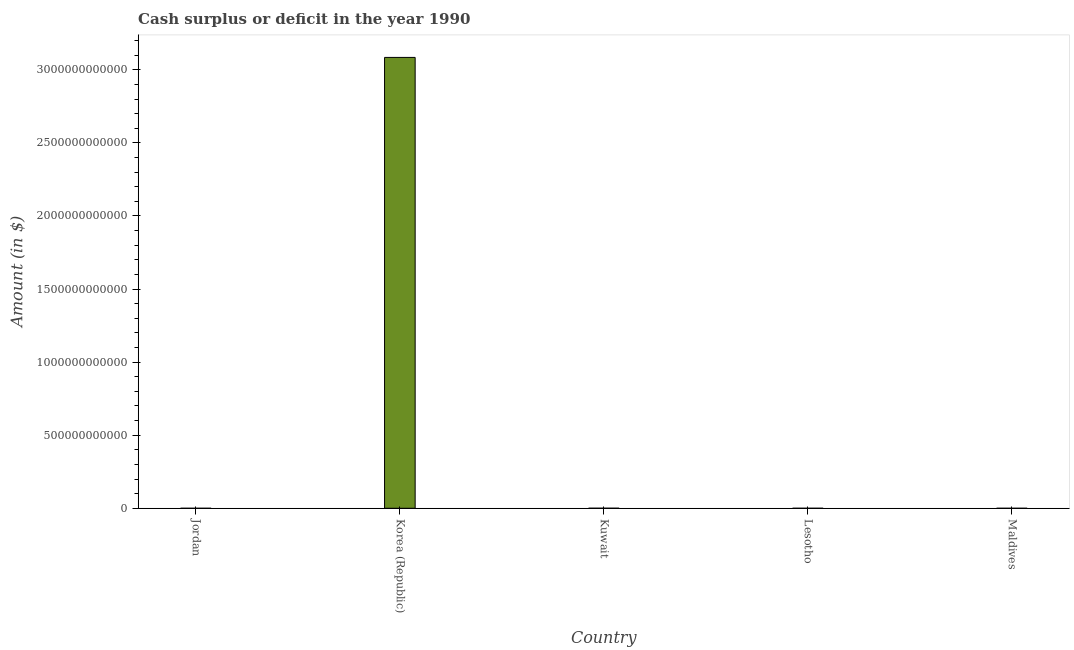What is the title of the graph?
Your answer should be compact. Cash surplus or deficit in the year 1990. What is the label or title of the Y-axis?
Provide a succinct answer. Amount (in $). What is the cash surplus or deficit in Kuwait?
Make the answer very short. 3.23e+08. Across all countries, what is the maximum cash surplus or deficit?
Give a very brief answer. 3.08e+12. In which country was the cash surplus or deficit maximum?
Provide a succinct answer. Korea (Republic). What is the sum of the cash surplus or deficit?
Ensure brevity in your answer.  3.09e+12. What is the average cash surplus or deficit per country?
Your response must be concise. 6.17e+11. What is the ratio of the cash surplus or deficit in Korea (Republic) to that in Kuwait?
Your answer should be compact. 9551.08. What is the difference between the highest and the lowest cash surplus or deficit?
Make the answer very short. 3.08e+12. Are all the bars in the graph horizontal?
Ensure brevity in your answer.  No. What is the difference between two consecutive major ticks on the Y-axis?
Offer a very short reply. 5.00e+11. What is the Amount (in $) of Korea (Republic)?
Provide a succinct answer. 3.08e+12. What is the Amount (in $) of Kuwait?
Give a very brief answer. 3.23e+08. What is the Amount (in $) of Lesotho?
Make the answer very short. 0. What is the difference between the Amount (in $) in Korea (Republic) and Kuwait?
Your response must be concise. 3.08e+12. What is the ratio of the Amount (in $) in Korea (Republic) to that in Kuwait?
Ensure brevity in your answer.  9551.08. 